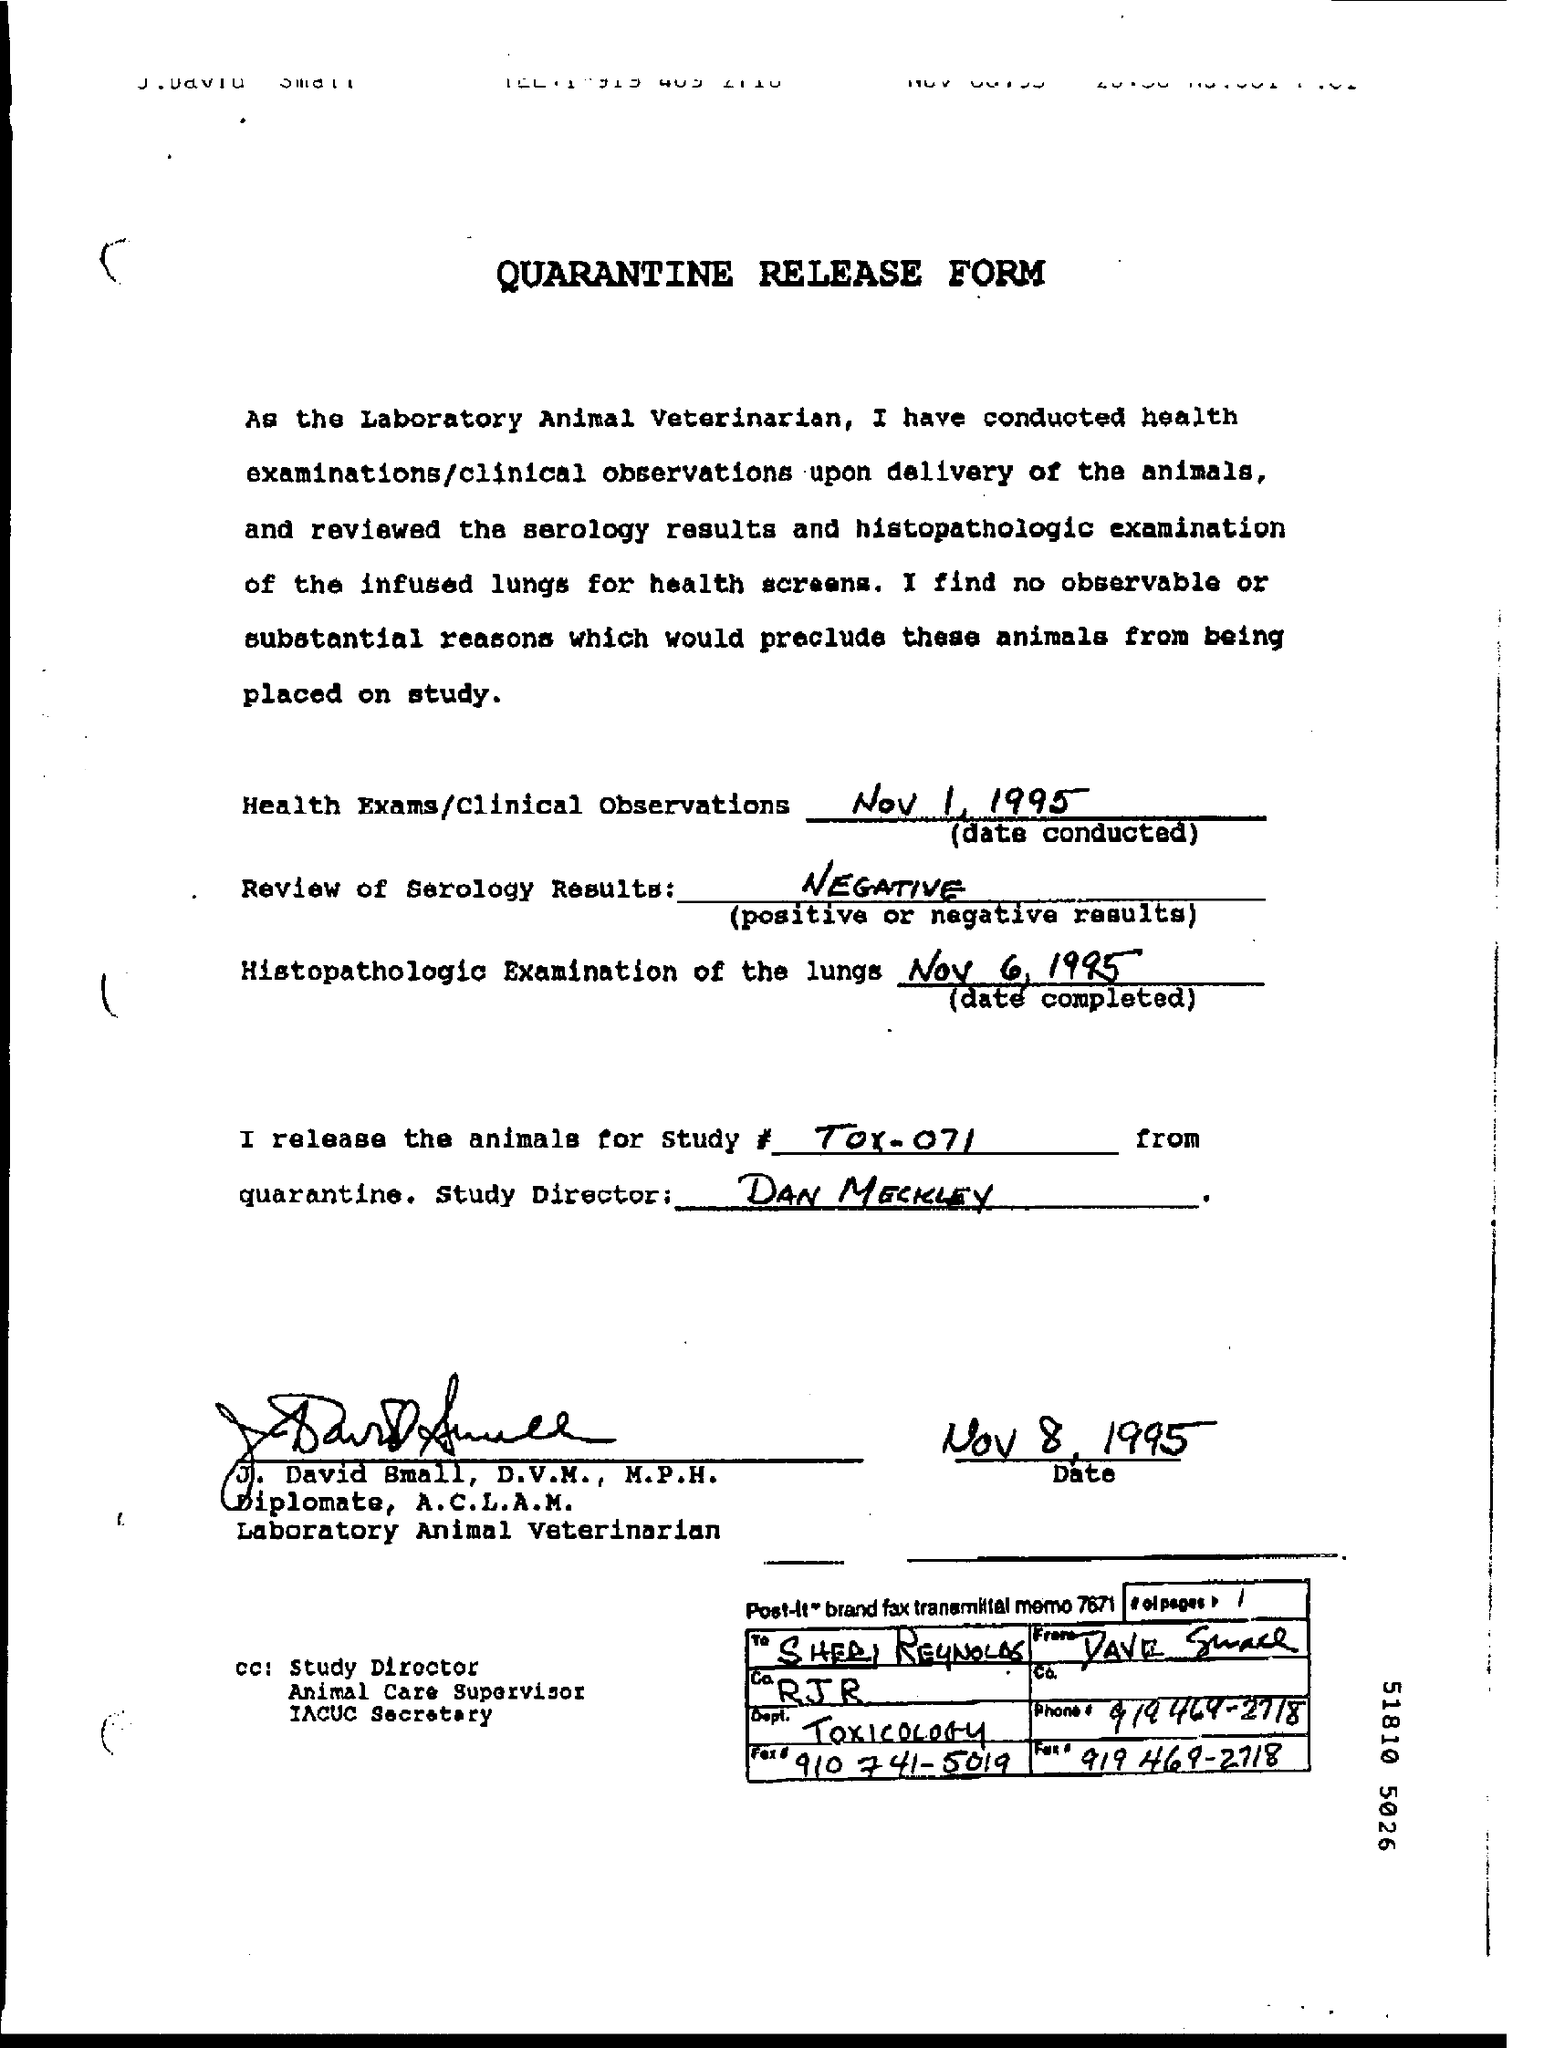Draw attention to some important aspects in this diagram. The study director mentioned in the form is Dan Meckley. The histopathologic examination of the lungs was completed on NOV 6, 1995. The treaty was signed on November 8, 1995. The result of the serology review is negative. This release form is addressed to Sheri Reynolds. 